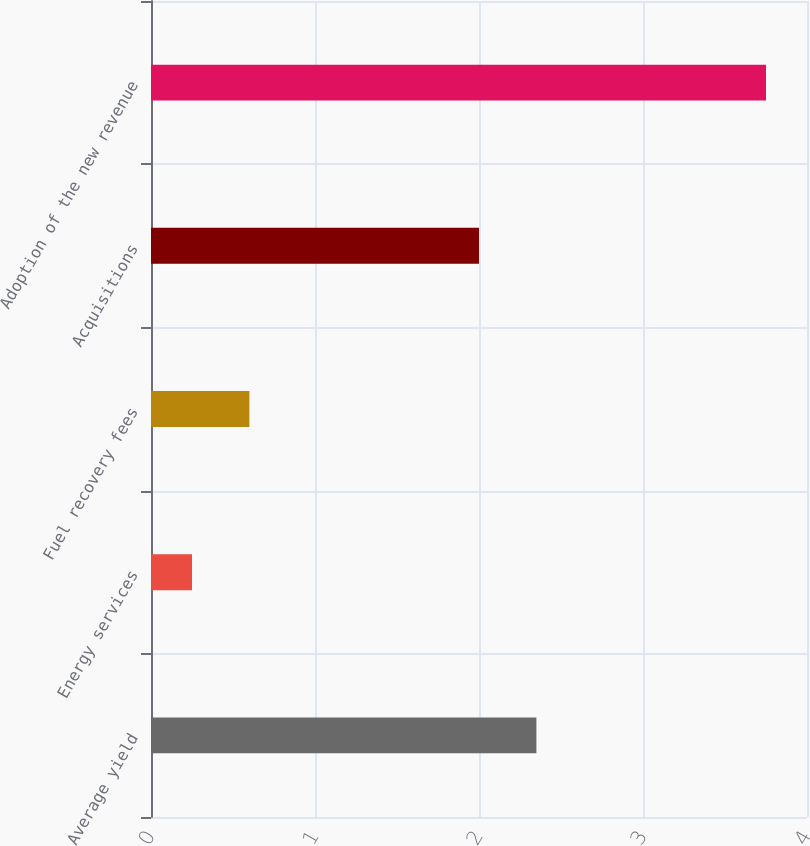Convert chart to OTSL. <chart><loc_0><loc_0><loc_500><loc_500><bar_chart><fcel>Average yield<fcel>Energy services<fcel>Fuel recovery fees<fcel>Acquisitions<fcel>Adoption of the new revenue<nl><fcel>2.35<fcel>0.25<fcel>0.6<fcel>2<fcel>3.75<nl></chart> 